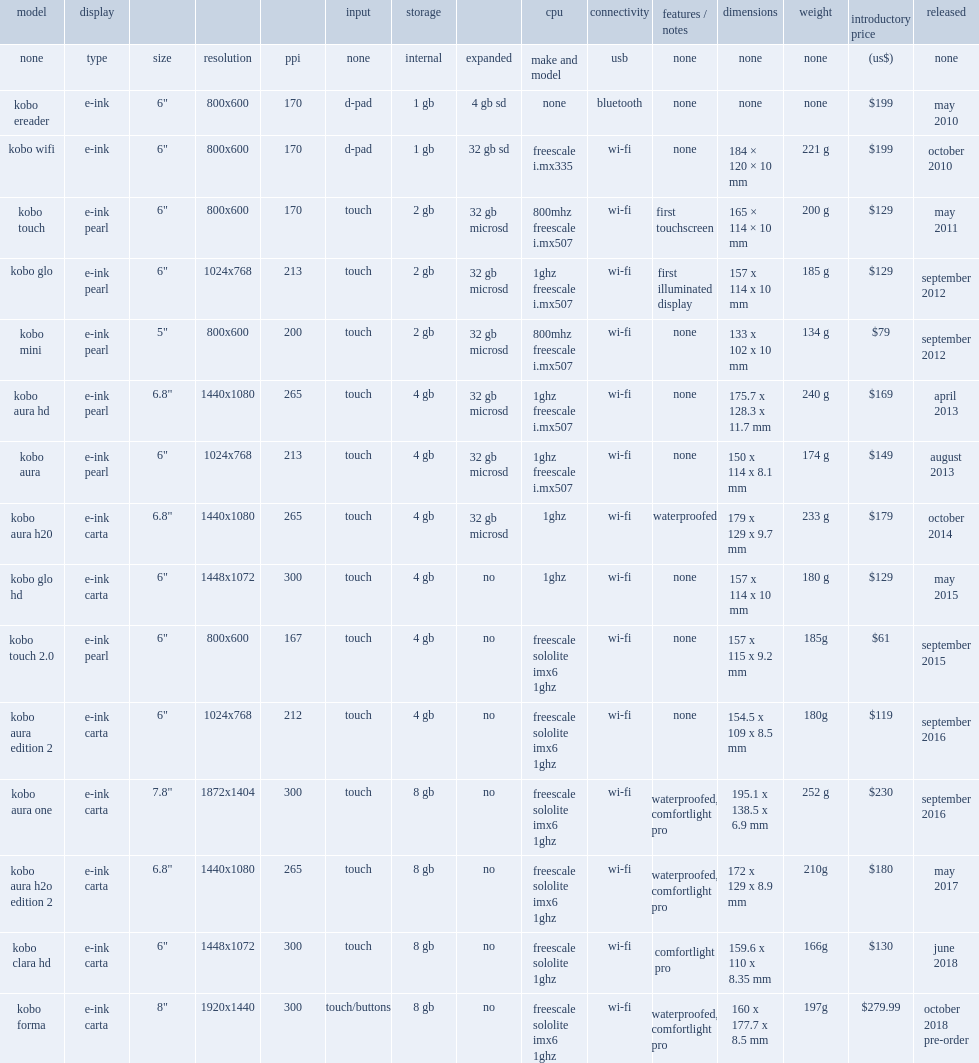What was kobo ereader's price? $199. 